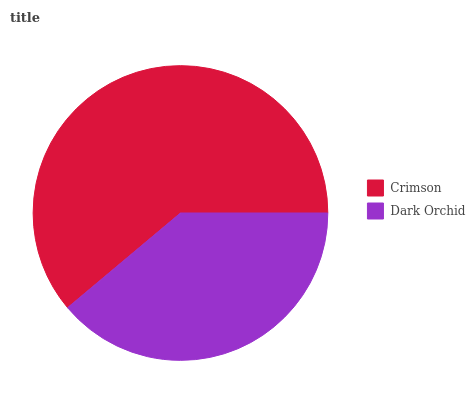Is Dark Orchid the minimum?
Answer yes or no. Yes. Is Crimson the maximum?
Answer yes or no. Yes. Is Dark Orchid the maximum?
Answer yes or no. No. Is Crimson greater than Dark Orchid?
Answer yes or no. Yes. Is Dark Orchid less than Crimson?
Answer yes or no. Yes. Is Dark Orchid greater than Crimson?
Answer yes or no. No. Is Crimson less than Dark Orchid?
Answer yes or no. No. Is Crimson the high median?
Answer yes or no. Yes. Is Dark Orchid the low median?
Answer yes or no. Yes. Is Dark Orchid the high median?
Answer yes or no. No. Is Crimson the low median?
Answer yes or no. No. 